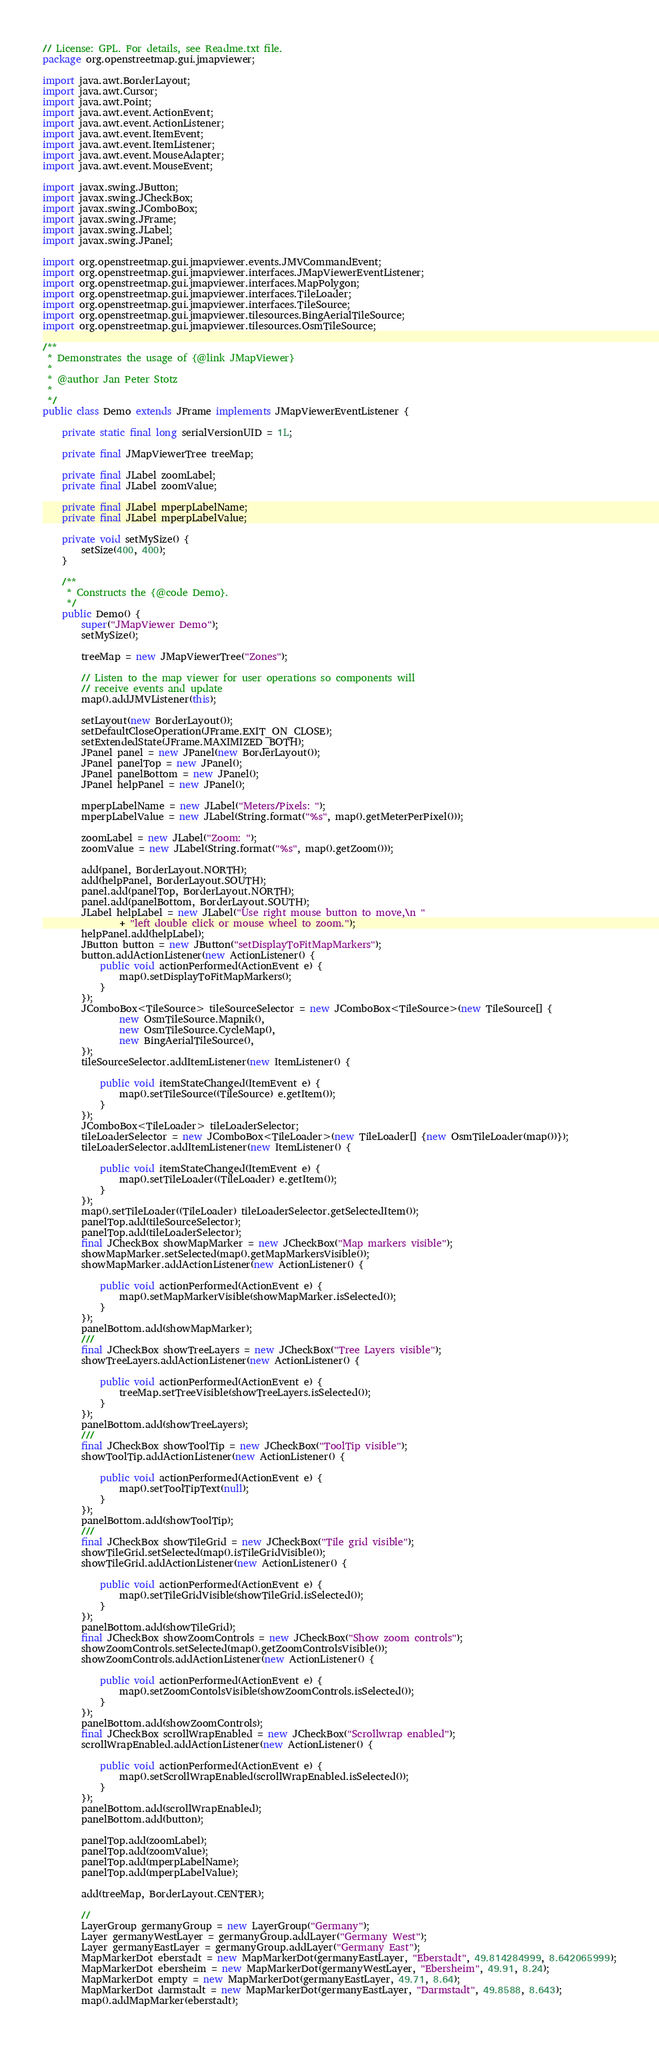<code> <loc_0><loc_0><loc_500><loc_500><_Java_>// License: GPL. For details, see Readme.txt file.
package org.openstreetmap.gui.jmapviewer;

import java.awt.BorderLayout;
import java.awt.Cursor;
import java.awt.Point;
import java.awt.event.ActionEvent;
import java.awt.event.ActionListener;
import java.awt.event.ItemEvent;
import java.awt.event.ItemListener;
import java.awt.event.MouseAdapter;
import java.awt.event.MouseEvent;

import javax.swing.JButton;
import javax.swing.JCheckBox;
import javax.swing.JComboBox;
import javax.swing.JFrame;
import javax.swing.JLabel;
import javax.swing.JPanel;

import org.openstreetmap.gui.jmapviewer.events.JMVCommandEvent;
import org.openstreetmap.gui.jmapviewer.interfaces.JMapViewerEventListener;
import org.openstreetmap.gui.jmapviewer.interfaces.MapPolygon;
import org.openstreetmap.gui.jmapviewer.interfaces.TileLoader;
import org.openstreetmap.gui.jmapviewer.interfaces.TileSource;
import org.openstreetmap.gui.jmapviewer.tilesources.BingAerialTileSource;
import org.openstreetmap.gui.jmapviewer.tilesources.OsmTileSource;

/**
 * Demonstrates the usage of {@link JMapViewer}
 *
 * @author Jan Peter Stotz
 *
 */
public class Demo extends JFrame implements JMapViewerEventListener {

    private static final long serialVersionUID = 1L;

    private final JMapViewerTree treeMap;

    private final JLabel zoomLabel;
    private final JLabel zoomValue;

    private final JLabel mperpLabelName;
    private final JLabel mperpLabelValue;
    
    private void setMySize() {
        setSize(400, 400);
    }

    /**
     * Constructs the {@code Demo}.
     */
    public Demo() {
        super("JMapViewer Demo");
        setMySize();

        treeMap = new JMapViewerTree("Zones");

        // Listen to the map viewer for user operations so components will
        // receive events and update
        map().addJMVListener(this);

        setLayout(new BorderLayout());
        setDefaultCloseOperation(JFrame.EXIT_ON_CLOSE);
        setExtendedState(JFrame.MAXIMIZED_BOTH);
        JPanel panel = new JPanel(new BorderLayout());
        JPanel panelTop = new JPanel();
        JPanel panelBottom = new JPanel();
        JPanel helpPanel = new JPanel();

        mperpLabelName = new JLabel("Meters/Pixels: ");
        mperpLabelValue = new JLabel(String.format("%s", map().getMeterPerPixel()));

        zoomLabel = new JLabel("Zoom: ");
        zoomValue = new JLabel(String.format("%s", map().getZoom()));

        add(panel, BorderLayout.NORTH);
        add(helpPanel, BorderLayout.SOUTH);
        panel.add(panelTop, BorderLayout.NORTH);
        panel.add(panelBottom, BorderLayout.SOUTH);
        JLabel helpLabel = new JLabel("Use right mouse button to move,\n "
                + "left double click or mouse wheel to zoom.");
        helpPanel.add(helpLabel);
        JButton button = new JButton("setDisplayToFitMapMarkers");
        button.addActionListener(new ActionListener() {
            public void actionPerformed(ActionEvent e) {
                map().setDisplayToFitMapMarkers();
            }
        });
        JComboBox<TileSource> tileSourceSelector = new JComboBox<TileSource>(new TileSource[] {
                new OsmTileSource.Mapnik(),
                new OsmTileSource.CycleMap(),
                new BingAerialTileSource(),
        });
        tileSourceSelector.addItemListener(new ItemListener() {
            
            public void itemStateChanged(ItemEvent e) {
                map().setTileSource((TileSource) e.getItem());
            }
        });
        JComboBox<TileLoader> tileLoaderSelector;
        tileLoaderSelector = new JComboBox<TileLoader>(new TileLoader[] {new OsmTileLoader(map())});
        tileLoaderSelector.addItemListener(new ItemListener() {
            
            public void itemStateChanged(ItemEvent e) {
                map().setTileLoader((TileLoader) e.getItem());
            }
        });
        map().setTileLoader((TileLoader) tileLoaderSelector.getSelectedItem());
        panelTop.add(tileSourceSelector);
        panelTop.add(tileLoaderSelector);
        final JCheckBox showMapMarker = new JCheckBox("Map markers visible");
        showMapMarker.setSelected(map().getMapMarkersVisible());
        showMapMarker.addActionListener(new ActionListener() {
            
            public void actionPerformed(ActionEvent e) {
                map().setMapMarkerVisible(showMapMarker.isSelected());
            }
        });
        panelBottom.add(showMapMarker);
        ///
        final JCheckBox showTreeLayers = new JCheckBox("Tree Layers visible");
        showTreeLayers.addActionListener(new ActionListener() {
            
            public void actionPerformed(ActionEvent e) {
                treeMap.setTreeVisible(showTreeLayers.isSelected());
            }
        });
        panelBottom.add(showTreeLayers);
        ///
        final JCheckBox showToolTip = new JCheckBox("ToolTip visible");
        showToolTip.addActionListener(new ActionListener() {
            
            public void actionPerformed(ActionEvent e) {
                map().setToolTipText(null);
            }
        });
        panelBottom.add(showToolTip);
        ///
        final JCheckBox showTileGrid = new JCheckBox("Tile grid visible");
        showTileGrid.setSelected(map().isTileGridVisible());
        showTileGrid.addActionListener(new ActionListener() {
            
            public void actionPerformed(ActionEvent e) {
                map().setTileGridVisible(showTileGrid.isSelected());
            }
        });
        panelBottom.add(showTileGrid);
        final JCheckBox showZoomControls = new JCheckBox("Show zoom controls");
        showZoomControls.setSelected(map().getZoomControlsVisible());
        showZoomControls.addActionListener(new ActionListener() {
            
            public void actionPerformed(ActionEvent e) {
                map().setZoomContolsVisible(showZoomControls.isSelected());
            }
        });
        panelBottom.add(showZoomControls);
        final JCheckBox scrollWrapEnabled = new JCheckBox("Scrollwrap enabled");
        scrollWrapEnabled.addActionListener(new ActionListener() {
            
            public void actionPerformed(ActionEvent e) {
                map().setScrollWrapEnabled(scrollWrapEnabled.isSelected());
            }
        });
        panelBottom.add(scrollWrapEnabled);
        panelBottom.add(button);

        panelTop.add(zoomLabel);
        panelTop.add(zoomValue);
        panelTop.add(mperpLabelName);
        panelTop.add(mperpLabelValue);

        add(treeMap, BorderLayout.CENTER);

        //
        LayerGroup germanyGroup = new LayerGroup("Germany");
        Layer germanyWestLayer = germanyGroup.addLayer("Germany West");
        Layer germanyEastLayer = germanyGroup.addLayer("Germany East");
        MapMarkerDot eberstadt = new MapMarkerDot(germanyEastLayer, "Eberstadt", 49.814284999, 8.642065999);
        MapMarkerDot ebersheim = new MapMarkerDot(germanyWestLayer, "Ebersheim", 49.91, 8.24);
        MapMarkerDot empty = new MapMarkerDot(germanyEastLayer, 49.71, 8.64);
        MapMarkerDot darmstadt = new MapMarkerDot(germanyEastLayer, "Darmstadt", 49.8588, 8.643);
        map().addMapMarker(eberstadt);</code> 